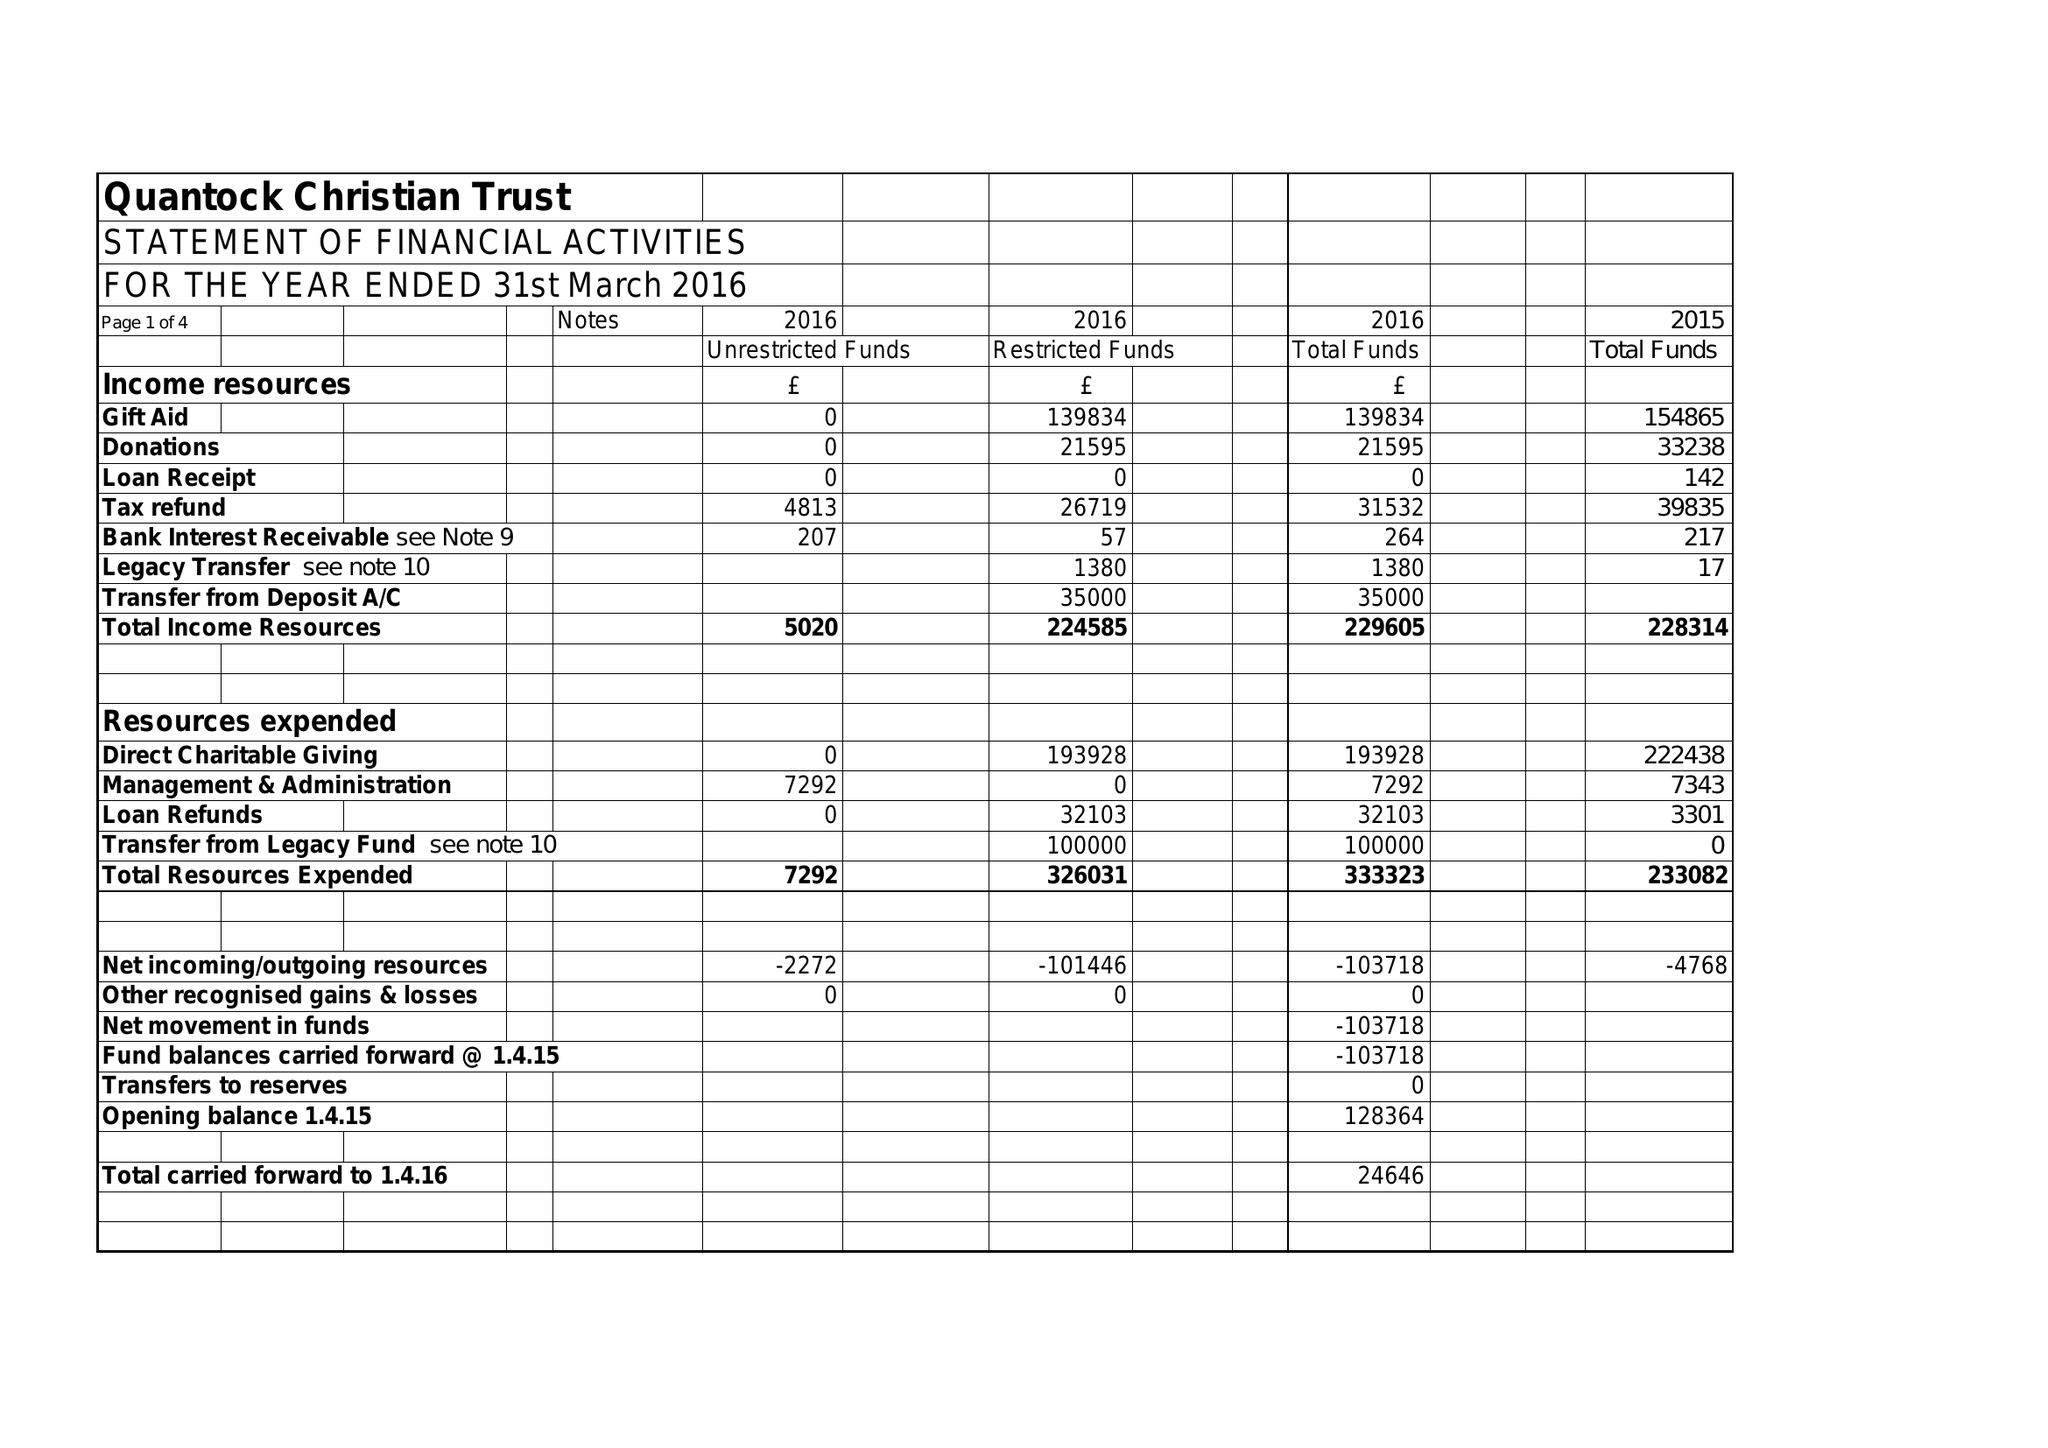What is the value for the charity_number?
Answer the question using a single word or phrase. 293349 